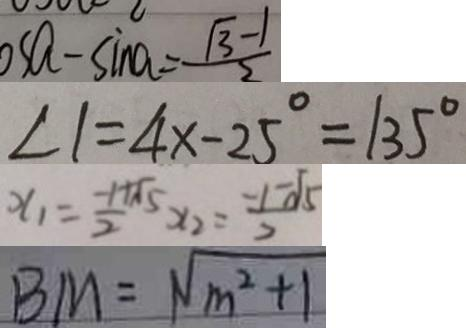<formula> <loc_0><loc_0><loc_500><loc_500>o s a - \sin a = \frac { \sqrt { 3 } - 1 } { 2 } 
 \angle 1 = 4 x - 2 5 ^ { \circ } = 1 3 5 ^ { \circ } 
 x _ { 1 } = \frac { - 1 + \sqrt { 5 } } { 2 } x _ { 2 } = \frac { - 1 - \sqrt { 5 } } { 2 } 
 B M = \sqrt { m ^ { 2 } + 1 }</formula> 